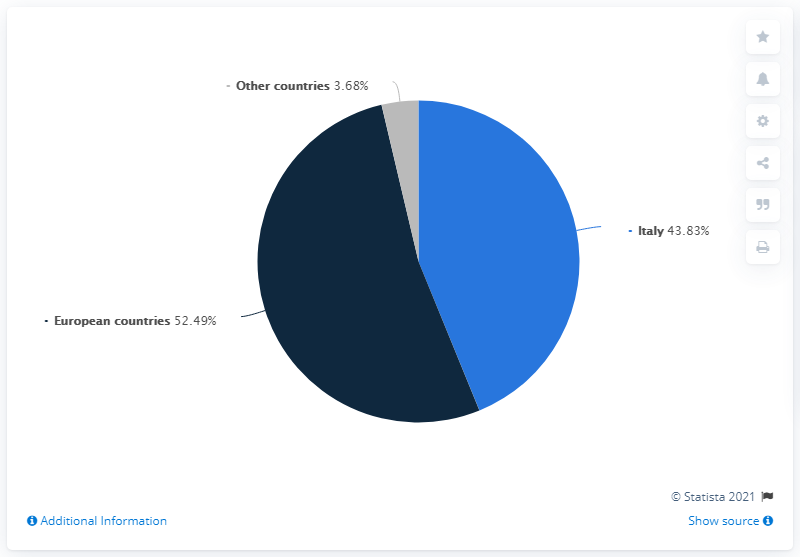Point out several critical features in this image. What is the difference between Italy and other countries? The average annual income in Italy is 40.15 times higher than the average annual income in other countries. Italy is represented by the color light blue in various contexts, such as sports events and international organizations. 